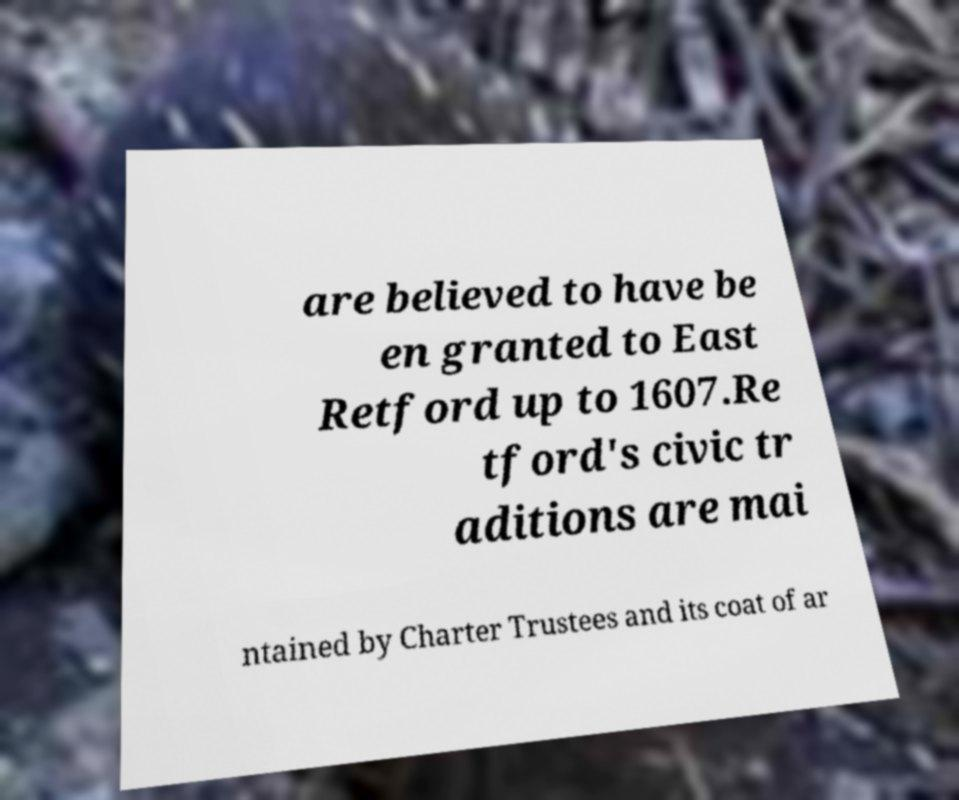I need the written content from this picture converted into text. Can you do that? are believed to have be en granted to East Retford up to 1607.Re tford's civic tr aditions are mai ntained by Charter Trustees and its coat of ar 